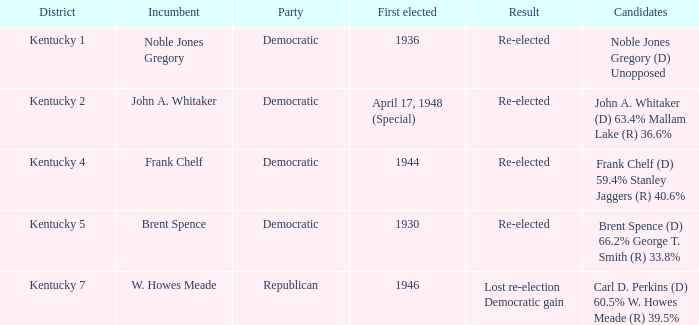What was the result in the voting district Kentucky 2? Re-elected. 